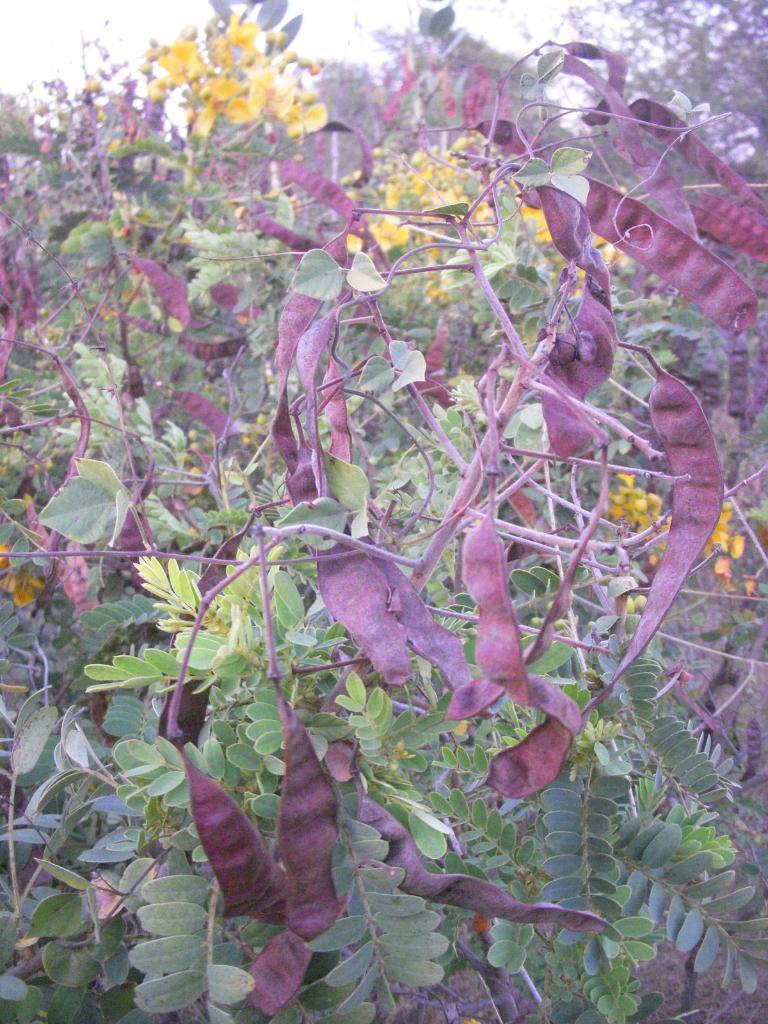Could you give a brief overview of what you see in this image? In this picture we can see plants with yellow flowers. 